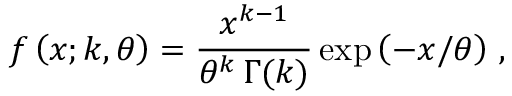<formula> <loc_0><loc_0><loc_500><loc_500>f \left ( x ; k , \theta \right ) = \frac { x ^ { k - 1 } } { \theta ^ { k } \, \Gamma ( k ) } \exp \left ( - x / \theta \right ) \, ,</formula> 